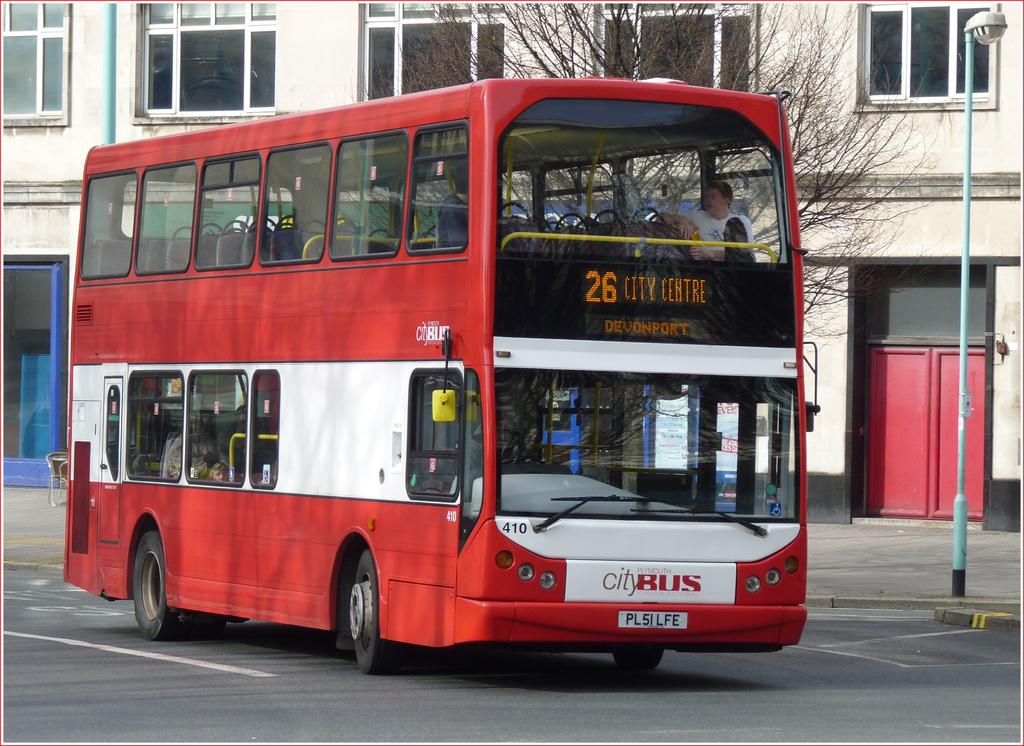<image>
Offer a succinct explanation of the picture presented. A red double decker bus with the number 26 and City Centre on it. 